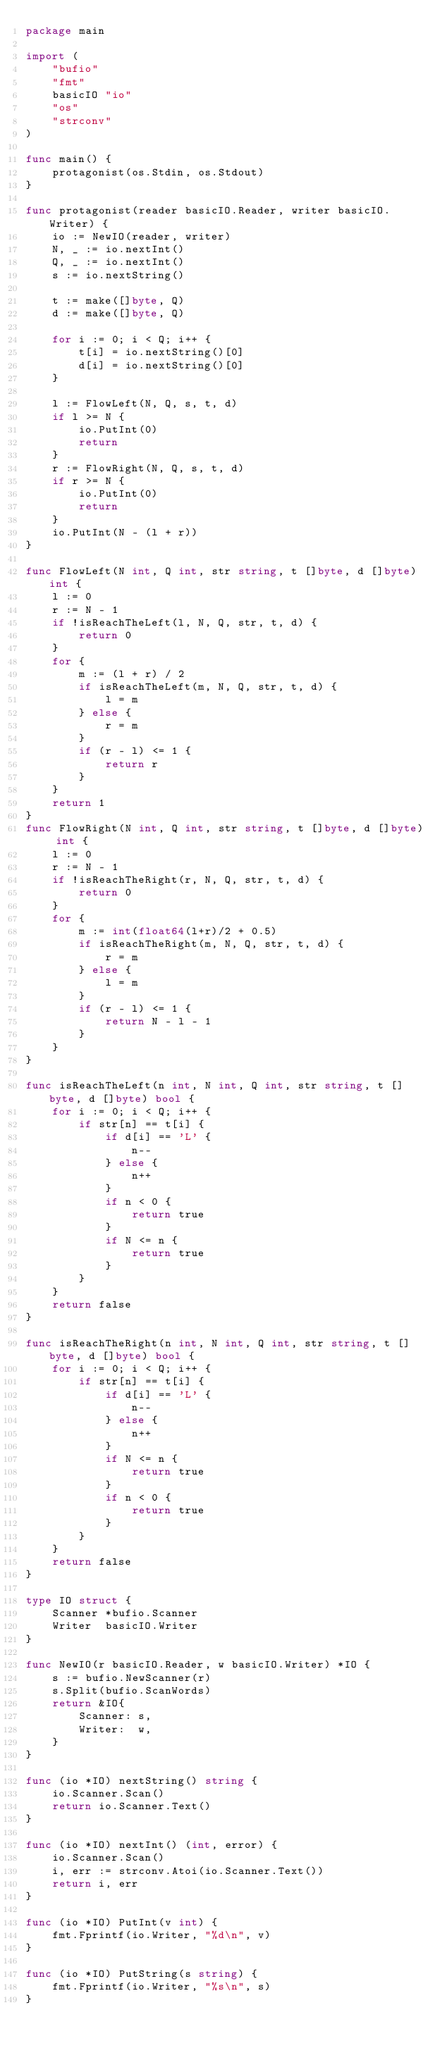Convert code to text. <code><loc_0><loc_0><loc_500><loc_500><_Go_>package main

import (
	"bufio"
	"fmt"
	basicIO "io"
	"os"
	"strconv"
)

func main() {
	protagonist(os.Stdin, os.Stdout)
}

func protagonist(reader basicIO.Reader, writer basicIO.Writer) {
	io := NewIO(reader, writer)
	N, _ := io.nextInt()
	Q, _ := io.nextInt()
	s := io.nextString()

	t := make([]byte, Q)
	d := make([]byte, Q)

	for i := 0; i < Q; i++ {
		t[i] = io.nextString()[0]
		d[i] = io.nextString()[0]
	}

	l := FlowLeft(N, Q, s, t, d)
	if l >= N {
		io.PutInt(0)
		return
	}
	r := FlowRight(N, Q, s, t, d)
	if r >= N {
		io.PutInt(0)
		return
	}
	io.PutInt(N - (l + r))
}

func FlowLeft(N int, Q int, str string, t []byte, d []byte) int {
	l := 0
	r := N - 1
	if !isReachTheLeft(l, N, Q, str, t, d) {
		return 0
	}
	for {
		m := (l + r) / 2
		if isReachTheLeft(m, N, Q, str, t, d) {
			l = m
		} else {
			r = m
		}
		if (r - l) <= 1 {
			return r
		}
	}
	return 1
}
func FlowRight(N int, Q int, str string, t []byte, d []byte) int {
	l := 0
	r := N - 1
	if !isReachTheRight(r, N, Q, str, t, d) {
		return 0
	}
	for {
		m := int(float64(l+r)/2 + 0.5)
		if isReachTheRight(m, N, Q, str, t, d) {
			r = m
		} else {
			l = m
		}
		if (r - l) <= 1 {
			return N - l - 1
		}
	}
}

func isReachTheLeft(n int, N int, Q int, str string, t []byte, d []byte) bool {
	for i := 0; i < Q; i++ {
		if str[n] == t[i] {
			if d[i] == 'L' {
				n--
			} else {
				n++
			}
			if n < 0 {
				return true
			}
			if N <= n {
				return true
			}
		}
	}
	return false
}

func isReachTheRight(n int, N int, Q int, str string, t []byte, d []byte) bool {
	for i := 0; i < Q; i++ {
		if str[n] == t[i] {
			if d[i] == 'L' {
				n--
			} else {
				n++
			}
			if N <= n {
				return true
			}
			if n < 0 {
				return true
			}
		}
	}
	return false
}

type IO struct {
	Scanner *bufio.Scanner
	Writer  basicIO.Writer
}

func NewIO(r basicIO.Reader, w basicIO.Writer) *IO {
	s := bufio.NewScanner(r)
	s.Split(bufio.ScanWords)
	return &IO{
		Scanner: s,
		Writer:  w,
	}
}

func (io *IO) nextString() string {
	io.Scanner.Scan()
	return io.Scanner.Text()
}

func (io *IO) nextInt() (int, error) {
	io.Scanner.Scan()
	i, err := strconv.Atoi(io.Scanner.Text())
	return i, err
}

func (io *IO) PutInt(v int) {
	fmt.Fprintf(io.Writer, "%d\n", v)
}

func (io *IO) PutString(s string) {
	fmt.Fprintf(io.Writer, "%s\n", s)
}
</code> 